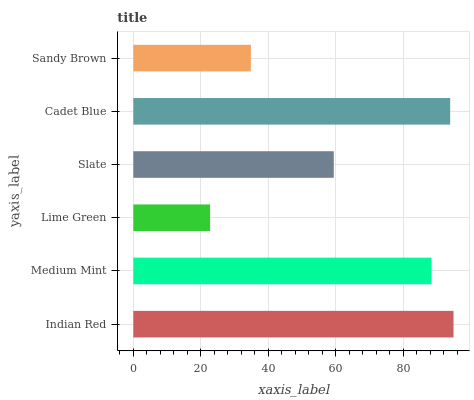Is Lime Green the minimum?
Answer yes or no. Yes. Is Indian Red the maximum?
Answer yes or no. Yes. Is Medium Mint the minimum?
Answer yes or no. No. Is Medium Mint the maximum?
Answer yes or no. No. Is Indian Red greater than Medium Mint?
Answer yes or no. Yes. Is Medium Mint less than Indian Red?
Answer yes or no. Yes. Is Medium Mint greater than Indian Red?
Answer yes or no. No. Is Indian Red less than Medium Mint?
Answer yes or no. No. Is Medium Mint the high median?
Answer yes or no. Yes. Is Slate the low median?
Answer yes or no. Yes. Is Indian Red the high median?
Answer yes or no. No. Is Sandy Brown the low median?
Answer yes or no. No. 